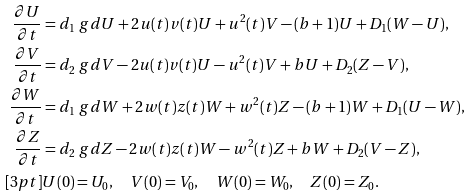Convert formula to latex. <formula><loc_0><loc_0><loc_500><loc_500>\frac { \partial U } { \partial t } & = d _ { 1 } \ g d U + 2 u ( t ) v ( t ) U + u ^ { 2 } ( t ) V - ( b + 1 ) U + D _ { 1 } ( W - U ) , \\ \frac { \partial V } { \partial t } & = d _ { 2 } \ g d V - 2 u ( t ) v ( t ) U - u ^ { 2 } ( t ) V + b U + D _ { 2 } ( Z - V ) , \\ \frac { \partial W } { \partial t } & = d _ { 1 } \ g d W + 2 w ( t ) z ( t ) W + w ^ { 2 } ( t ) Z - ( b + 1 ) W + D _ { 1 } ( U - W ) , \\ \frac { \partial Z } { \partial t } & = d _ { 2 } \ g d Z - 2 w ( t ) z ( t ) W - w ^ { 2 } ( t ) Z + b W + D _ { 2 } ( V - Z ) , \\ [ 3 p t ] & U ( 0 ) = U _ { 0 } , \quad V ( 0 ) = V _ { 0 } , \quad W ( 0 ) = W _ { 0 } , \quad Z ( 0 ) = Z _ { 0 } .</formula> 